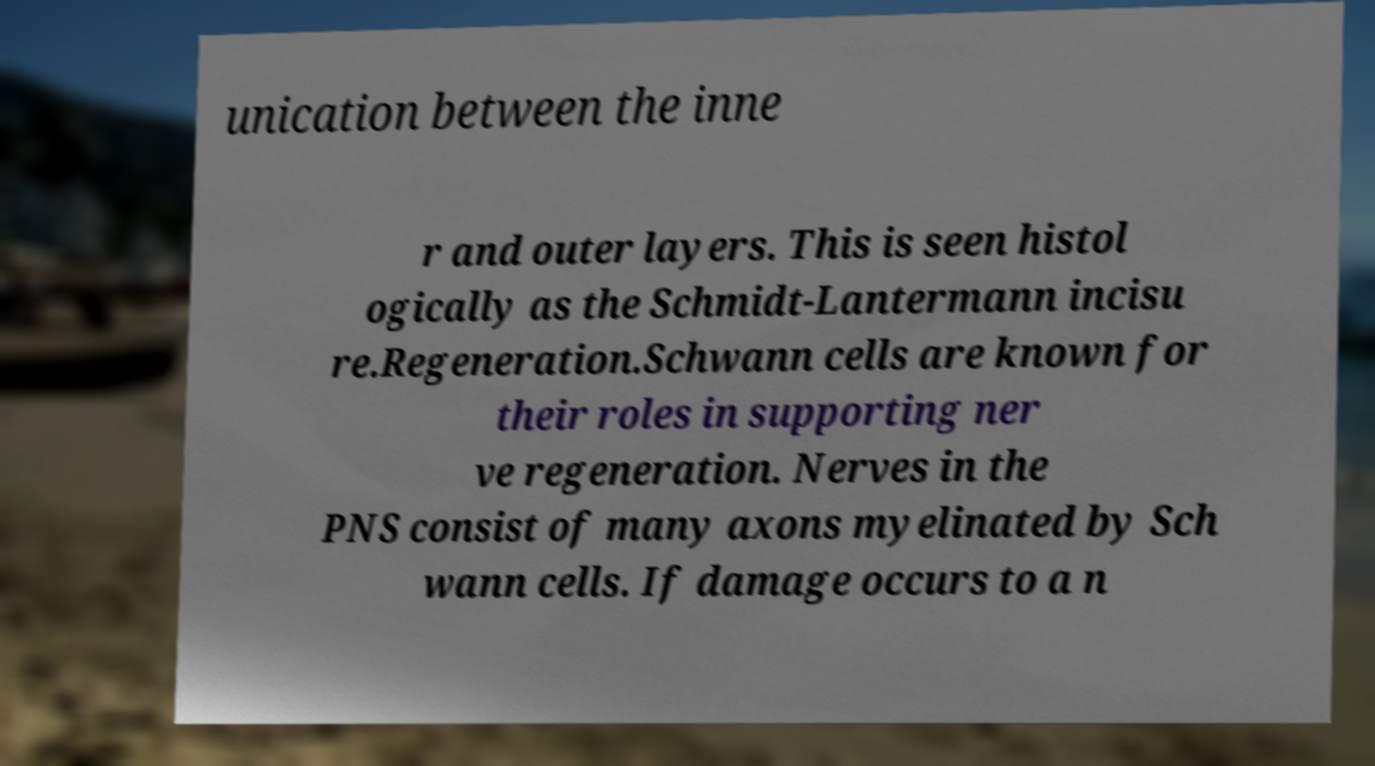For documentation purposes, I need the text within this image transcribed. Could you provide that? unication between the inne r and outer layers. This is seen histol ogically as the Schmidt-Lantermann incisu re.Regeneration.Schwann cells are known for their roles in supporting ner ve regeneration. Nerves in the PNS consist of many axons myelinated by Sch wann cells. If damage occurs to a n 